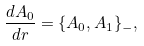<formula> <loc_0><loc_0><loc_500><loc_500>\frac { d A _ { 0 } } { d r } = \{ A _ { 0 } , A _ { 1 } \} _ { - } ,</formula> 